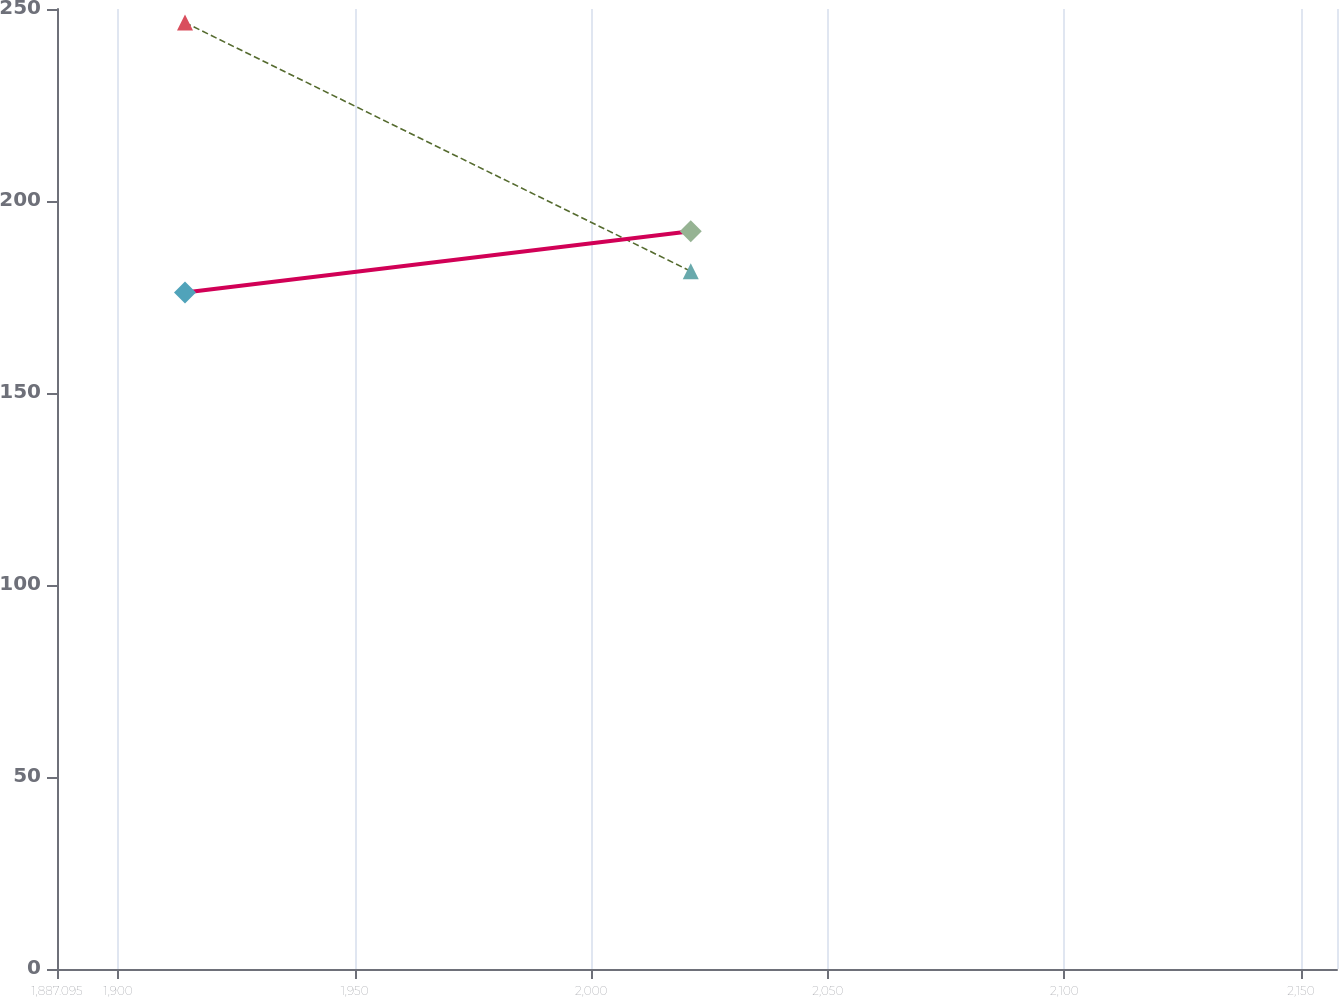Convert chart to OTSL. <chart><loc_0><loc_0><loc_500><loc_500><line_chart><ecel><fcel>$79 Benefit payments reflecting expected future service, as appropriate, are expected to be paid as<fcel>$(70)<nl><fcel>1914.15<fcel>246.46<fcel>176.17<nl><fcel>2021.05<fcel>181.7<fcel>192.12<nl><fcel>2184.7<fcel>240.31<fcel>245.61<nl></chart> 